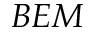Convert formula to latex. <formula><loc_0><loc_0><loc_500><loc_500>B E M</formula> 